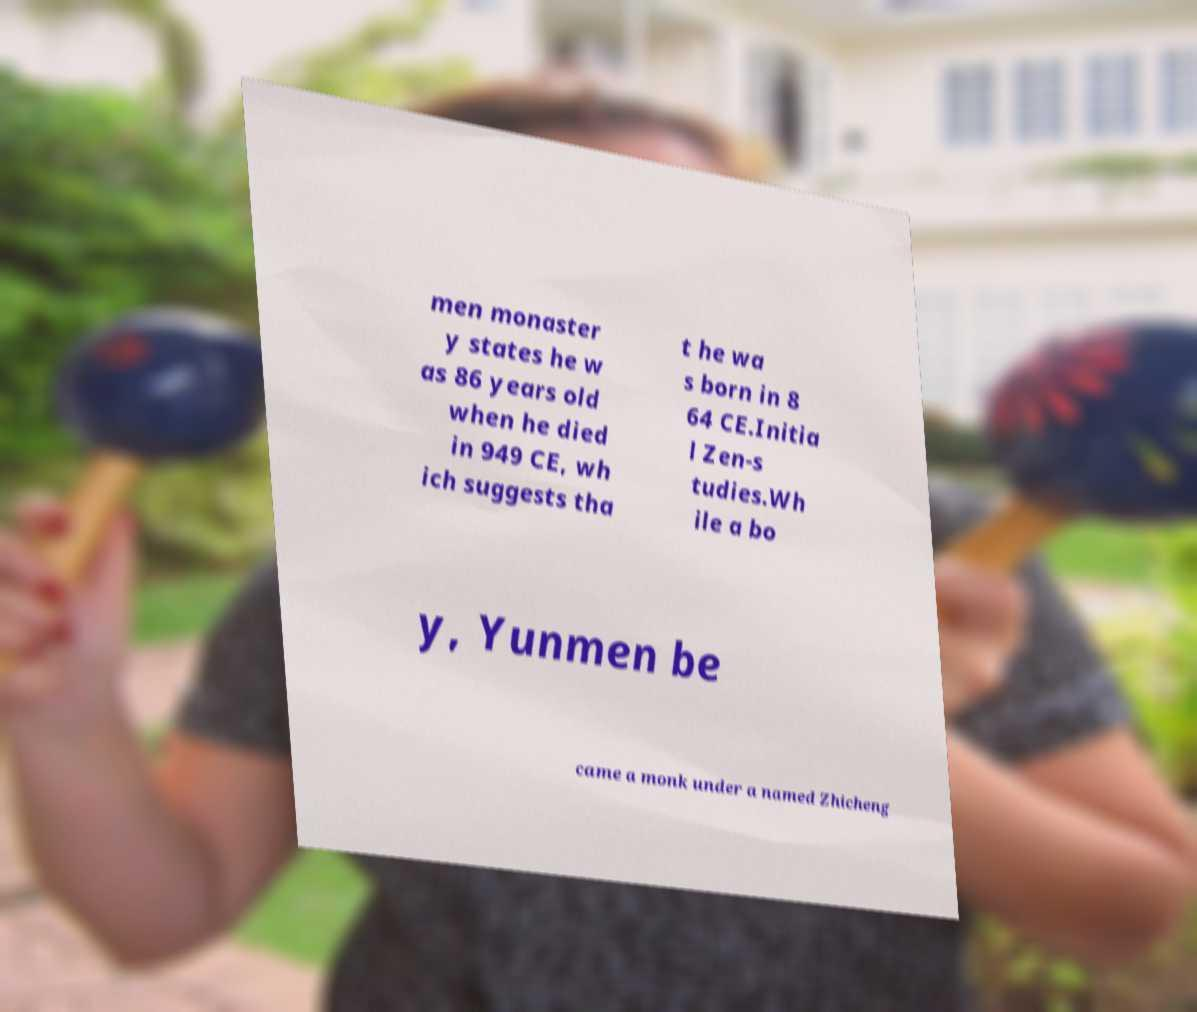Please read and relay the text visible in this image. What does it say? men monaster y states he w as 86 years old when he died in 949 CE, wh ich suggests tha t he wa s born in 8 64 CE.Initia l Zen-s tudies.Wh ile a bo y, Yunmen be came a monk under a named Zhicheng 